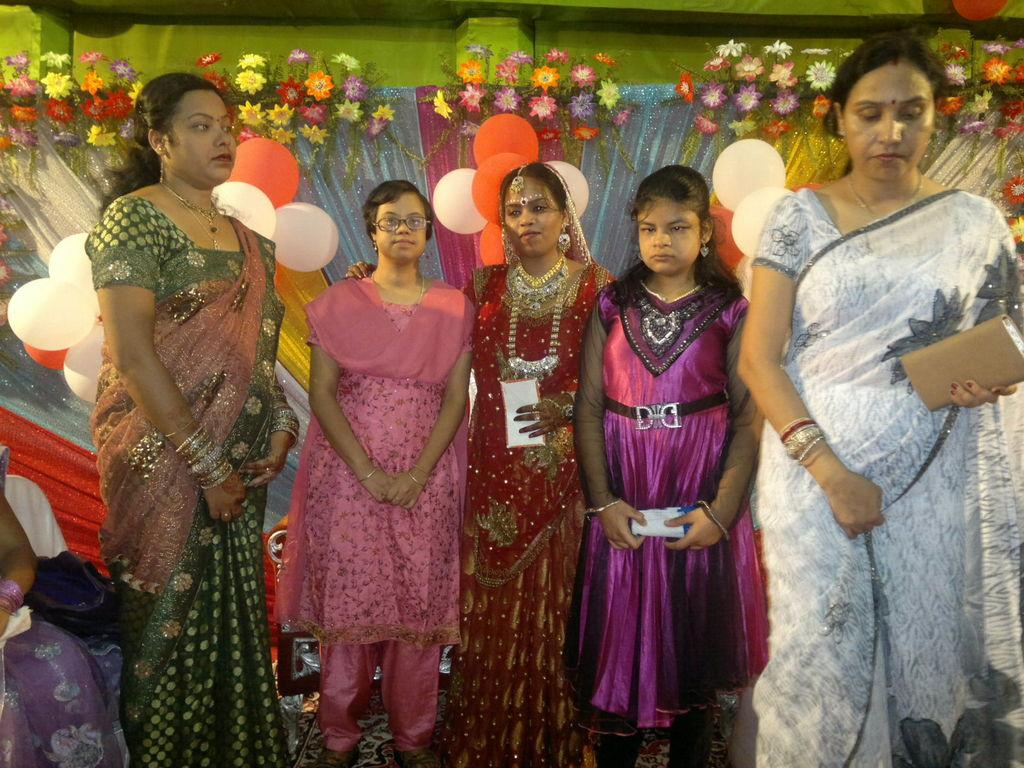How many people are in the image? There are people in the image, but the exact number is not specified. What are some of the people in the image doing? Some people are standing. What can be seen in the background of the image? There are balloons, flowers, colorful curtains, and a wall in the background. What type of hair can be seen on the rabbit in the image? There is no rabbit present in the image, so there is no hair to describe. 